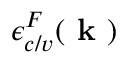<formula> <loc_0><loc_0><loc_500><loc_500>\epsilon _ { c / v } ^ { F } ( k )</formula> 